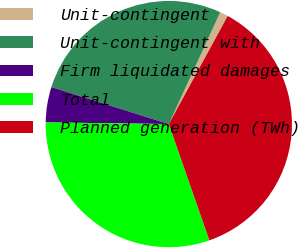Convert chart to OTSL. <chart><loc_0><loc_0><loc_500><loc_500><pie_chart><fcel>Unit-contingent<fcel>Unit-contingent with<fcel>Firm liquidated damages<fcel>Total<fcel>Planned generation (TWh)<nl><fcel>1.08%<fcel>27.0%<fcel>4.64%<fcel>30.56%<fcel>36.72%<nl></chart> 